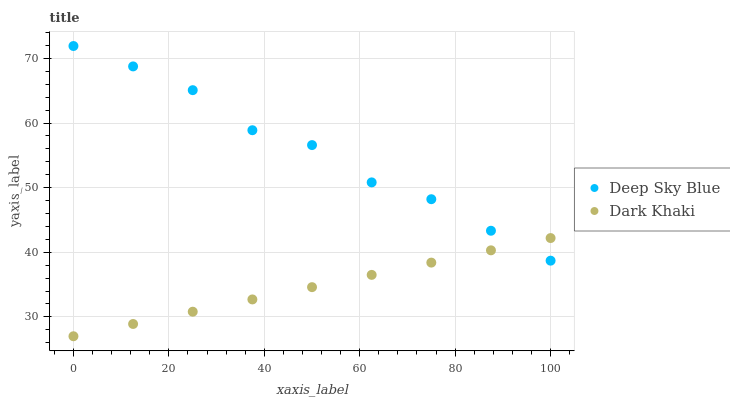Does Dark Khaki have the minimum area under the curve?
Answer yes or no. Yes. Does Deep Sky Blue have the maximum area under the curve?
Answer yes or no. Yes. Does Deep Sky Blue have the minimum area under the curve?
Answer yes or no. No. Is Dark Khaki the smoothest?
Answer yes or no. Yes. Is Deep Sky Blue the roughest?
Answer yes or no. Yes. Is Deep Sky Blue the smoothest?
Answer yes or no. No. Does Dark Khaki have the lowest value?
Answer yes or no. Yes. Does Deep Sky Blue have the lowest value?
Answer yes or no. No. Does Deep Sky Blue have the highest value?
Answer yes or no. Yes. Does Dark Khaki intersect Deep Sky Blue?
Answer yes or no. Yes. Is Dark Khaki less than Deep Sky Blue?
Answer yes or no. No. Is Dark Khaki greater than Deep Sky Blue?
Answer yes or no. No. 